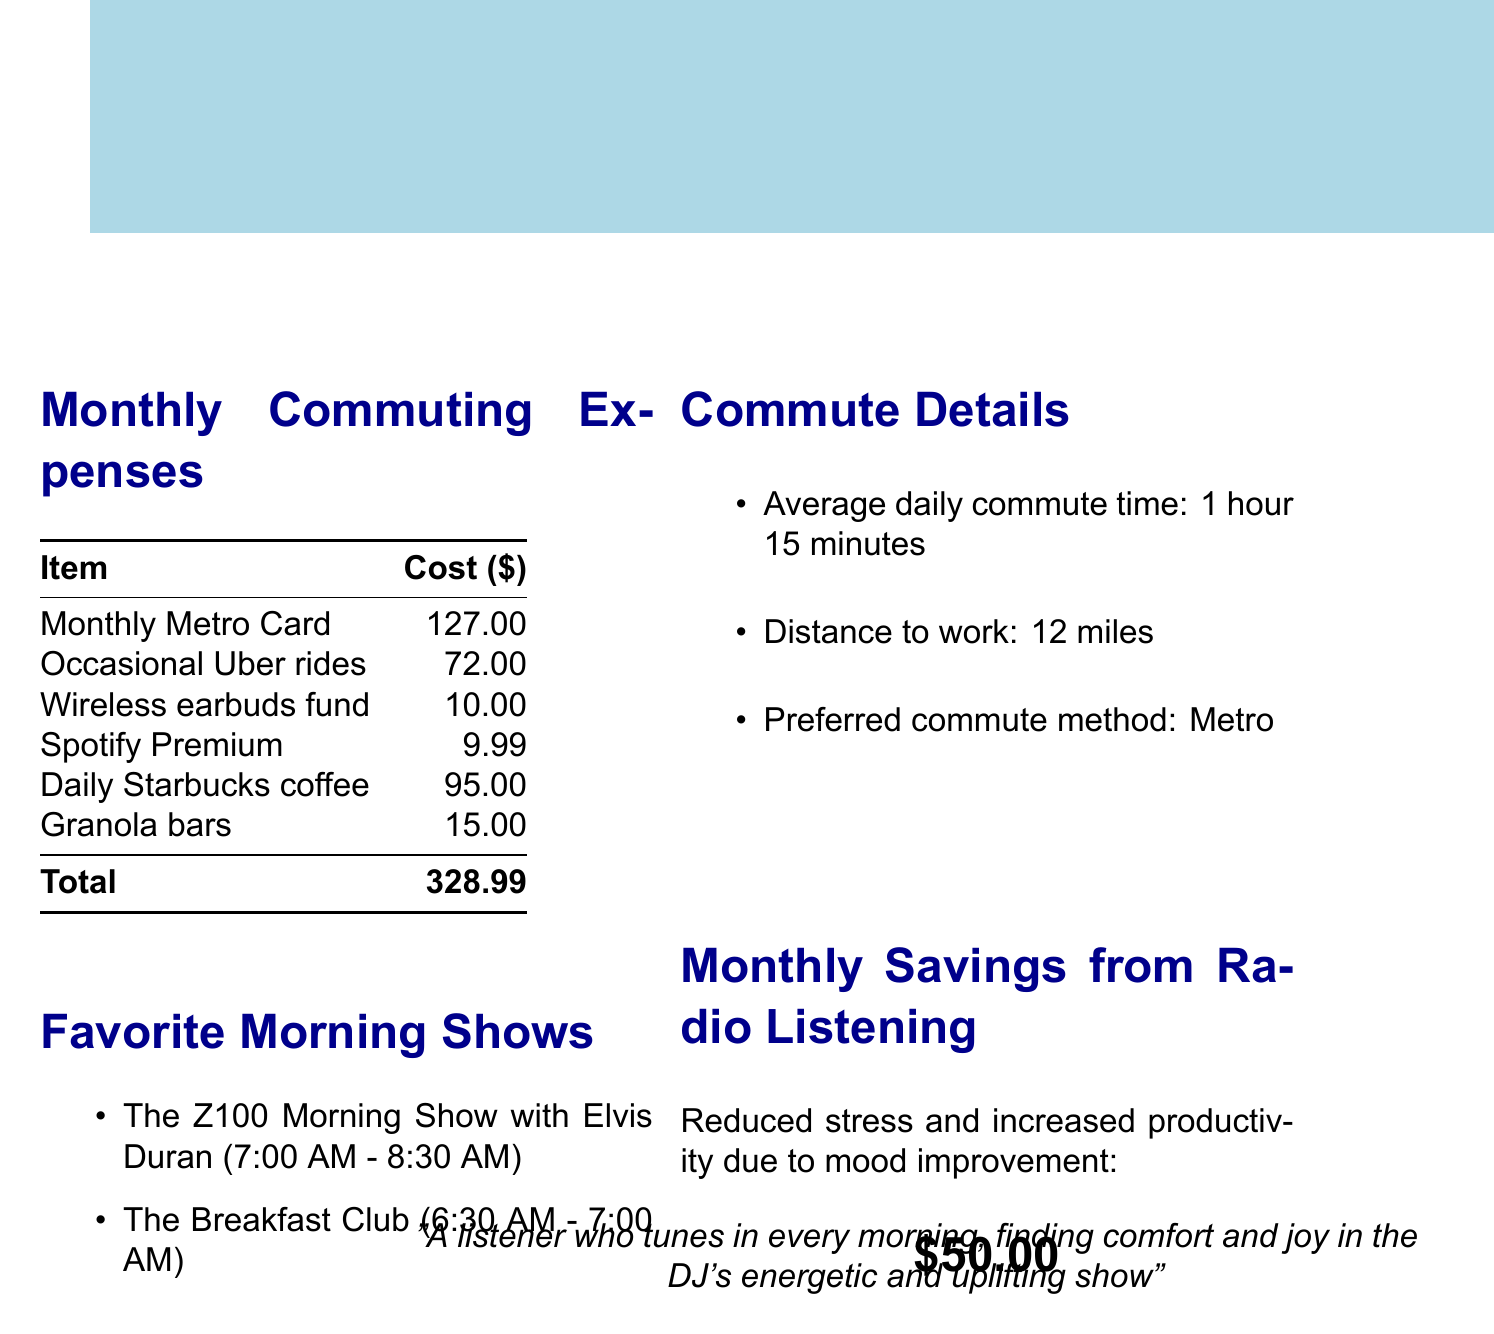What is the total cost of monthly commuting expenses? The total cost is calculated by adding all individual costs in the commuting expenses section, which equals 127.00 + 72.00 + 10.00 + 9.99 + 95.00 + 15.00 = 328.99.
Answer: 328.99 What is the cost of a Monthly Metro Card? The document specifies that the cost of a Monthly Metro Card is provided as an individual item in the expenses section.
Answer: 127.00 How many Uber rides are taken per month? The document states "Occasional Uber rides (4 per month)," indicating the monthly frequency.
Answer: 4 What is the estimated value of monthly savings from radio listening? The document provides an estimated value, which represents the financial benefit derived from listening to radio shows while commuting.
Answer: 50.00 What are the names of the favorite morning shows? By listing the favorite shows in the document, the names can be easily retrieved for reference.
Answer: The Z100 Morning Show with Elvis Duran, The Breakfast Club What is the average daily commute time? The average daily commute time is documented as a specific duration under the commute details section of the report.
Answer: 1 hour 15 minutes What is the preferred commuting method? The preferred commuting method is directly stated in the commute details section.
Answer: Metro What is the total cost of snacks and beverages? By summing the costs of daily coffee and granola bars, it can be derived from the expenses section, which includes 95.00 + 15.00.
Answer: 110.00 Which radio subscription allows for offline listening? The document lists various radio equipment, specifying that the subscription in question is for offline music access.
Answer: Spotify Premium 